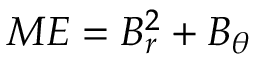Convert formula to latex. <formula><loc_0><loc_0><loc_500><loc_500>M E = B _ { r } ^ { 2 } + B _ { \theta }</formula> 